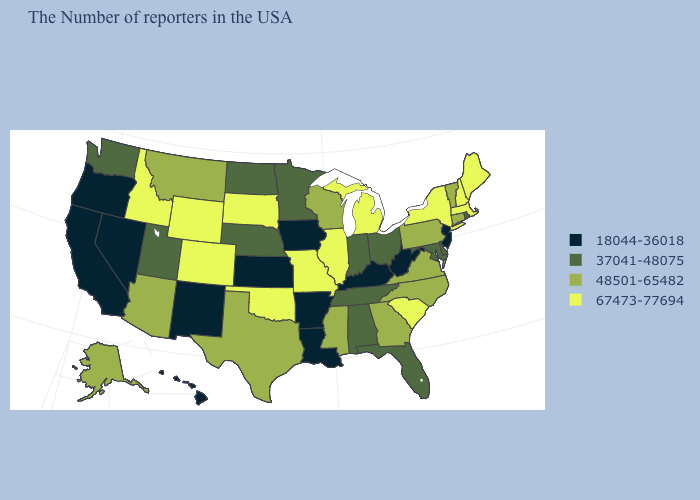What is the highest value in the USA?
Give a very brief answer. 67473-77694. Which states have the highest value in the USA?
Short answer required. Maine, Massachusetts, New Hampshire, New York, South Carolina, Michigan, Illinois, Missouri, Oklahoma, South Dakota, Wyoming, Colorado, Idaho. What is the value of Georgia?
Be succinct. 48501-65482. Does Rhode Island have the same value as Virginia?
Short answer required. No. What is the value of Vermont?
Answer briefly. 48501-65482. Does Connecticut have the lowest value in the USA?
Write a very short answer. No. Name the states that have a value in the range 48501-65482?
Write a very short answer. Vermont, Connecticut, Pennsylvania, Virginia, North Carolina, Georgia, Wisconsin, Mississippi, Texas, Montana, Arizona, Alaska. Name the states that have a value in the range 48501-65482?
Keep it brief. Vermont, Connecticut, Pennsylvania, Virginia, North Carolina, Georgia, Wisconsin, Mississippi, Texas, Montana, Arizona, Alaska. Among the states that border Vermont , which have the lowest value?
Give a very brief answer. Massachusetts, New Hampshire, New York. Name the states that have a value in the range 18044-36018?
Quick response, please. New Jersey, West Virginia, Kentucky, Louisiana, Arkansas, Iowa, Kansas, New Mexico, Nevada, California, Oregon, Hawaii. Name the states that have a value in the range 48501-65482?
Give a very brief answer. Vermont, Connecticut, Pennsylvania, Virginia, North Carolina, Georgia, Wisconsin, Mississippi, Texas, Montana, Arizona, Alaska. Does Massachusetts have the same value as Wyoming?
Write a very short answer. Yes. What is the value of North Dakota?
Write a very short answer. 37041-48075. What is the value of Maine?
Give a very brief answer. 67473-77694. 